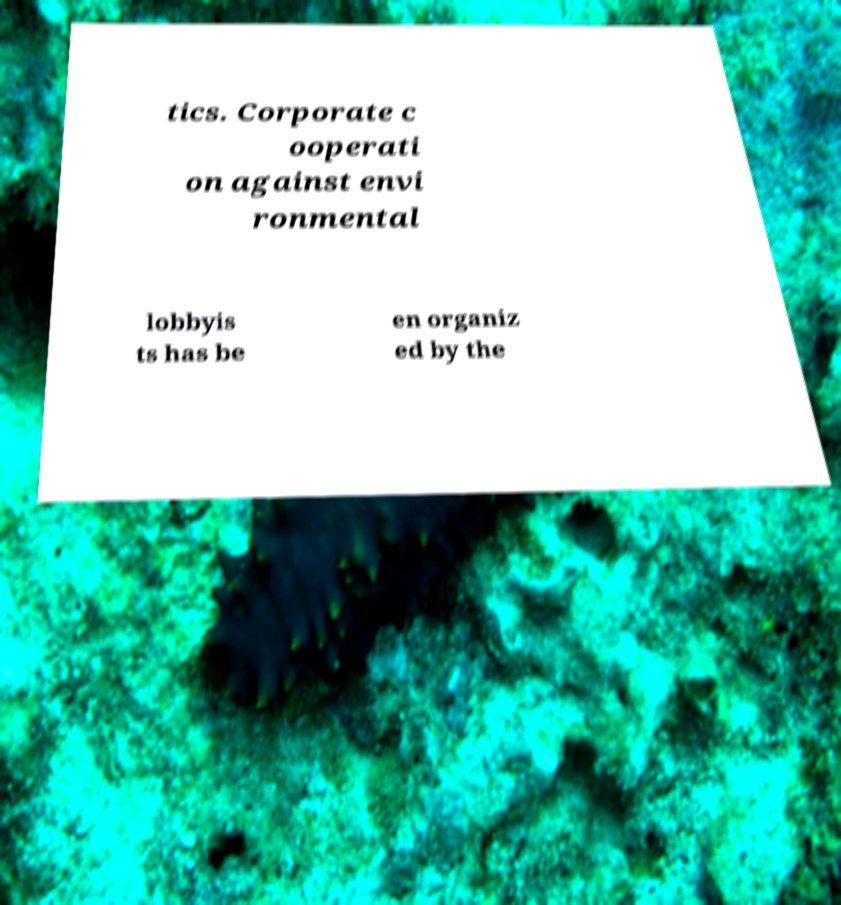Can you read and provide the text displayed in the image?This photo seems to have some interesting text. Can you extract and type it out for me? tics. Corporate c ooperati on against envi ronmental lobbyis ts has be en organiz ed by the 